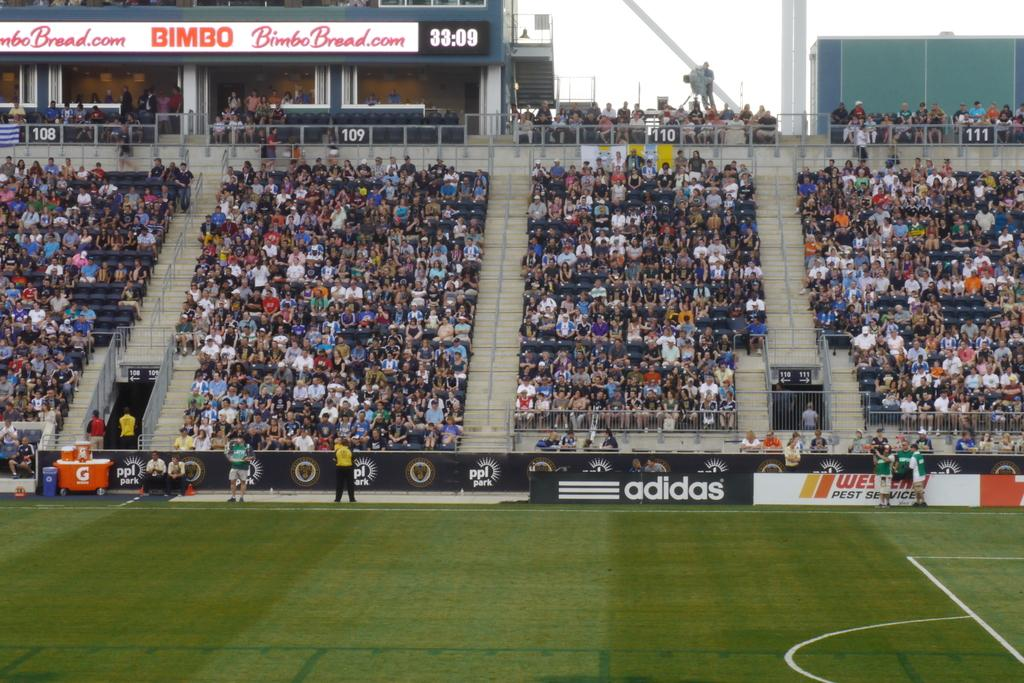<image>
Describe the image concisely. A shot of the stands in a soccer arena and an adidas advertisement 